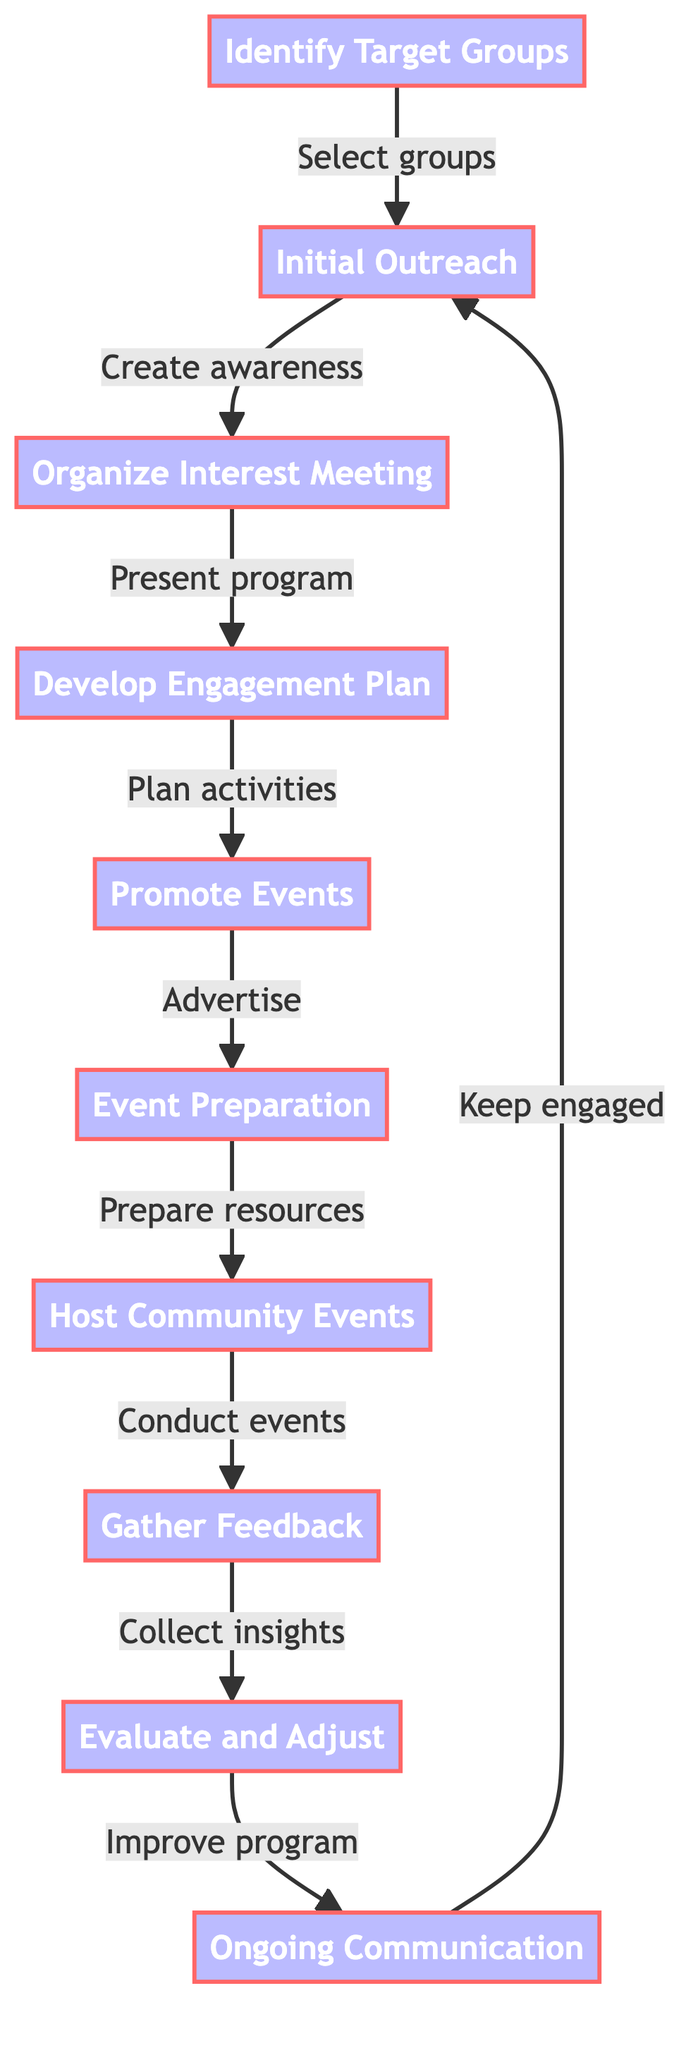What is the first step in the community engagement process? The first step is "Identify Target Groups," which is the starting node in the flowchart.
Answer: Identify Target Groups How many steps are in the flowchart? The flowchart contains ten steps, as indicated by the total number of nodes listed.
Answer: 10 What step follows "Promote Events"? "Event Preparation" directly follows "Promote Events," as shown by the arrow connecting the two nodes.
Answer: Event Preparation Which step involves collecting feedback? The step titled "Gather Feedback" is focused on collecting insights from participants about the events.
Answer: Gather Feedback What is the last step in the process? The last step of the community engagement process is "Ongoing Communication," which wraps up the flow by connecting back to "Initial Outreach."
Answer: Ongoing Communication What is the purpose of the "Organize Interest Meeting"? The purpose is to present the goals, benefits, and logistics of the soccer program, according to the description provided for that step.
Answer: Present program What happens after the "Host Community Events"? After hosting community events, the next step is to "Gather Feedback," which emphasizes assessing the effectiveness of the activities.
Answer: Gather Feedback Which two steps directly connect to "Evaluate and Adjust"? "Gather Feedback" feeds into "Evaluate and Adjust," as well as the continuous loop connecting to "Ongoing Communication."
Answer: Gather Feedback and Ongoing Communication How does the flowchart ensure continuous improvement? Continuous improvement is ensured by the loop that goes from "Evaluate and Adjust" back to "Ongoing Communication," maintaining engagement with the community.
Answer: Ongoing Communication What medium is mentioned for initial outreach to community groups? The mediums mentioned include emails, social media, flyers, and in-person visits based on the outreach step's description.
Answer: Emails, social media, flyers, in-person visits 